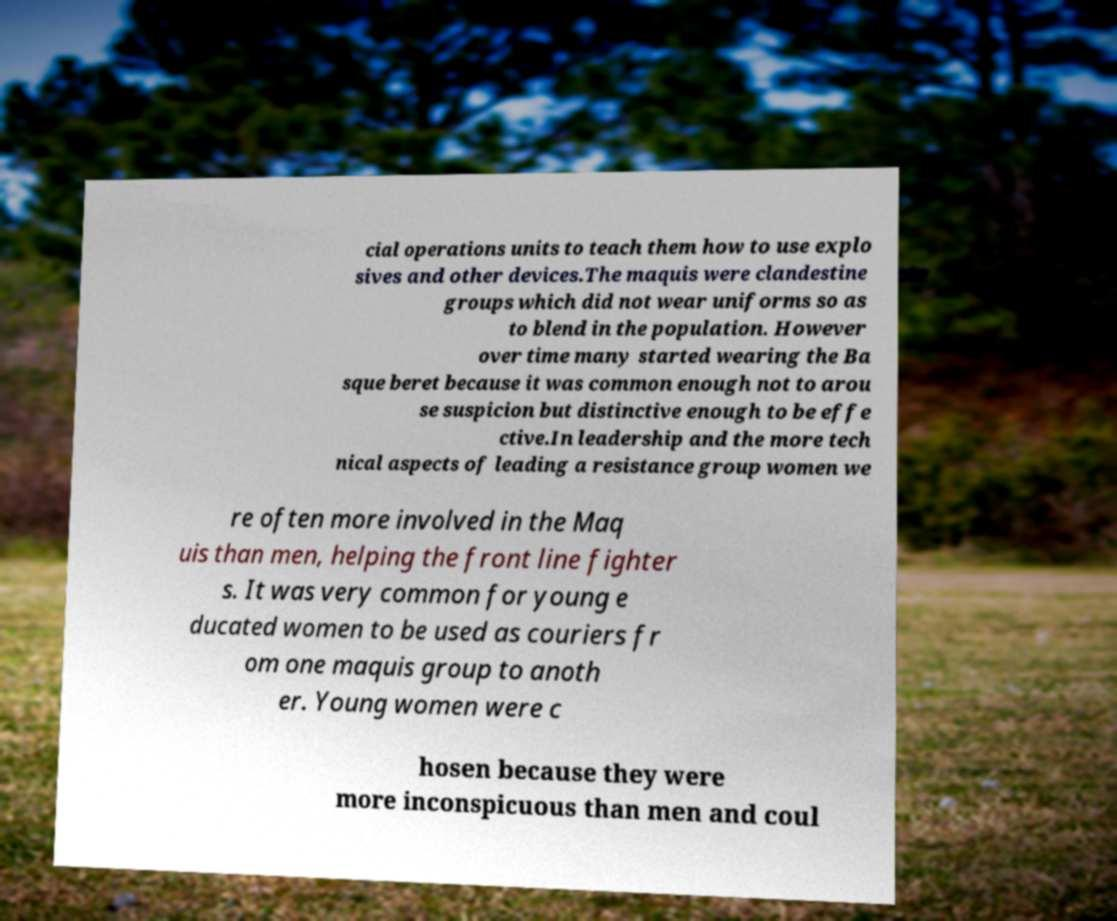Could you assist in decoding the text presented in this image and type it out clearly? cial operations units to teach them how to use explo sives and other devices.The maquis were clandestine groups which did not wear uniforms so as to blend in the population. However over time many started wearing the Ba sque beret because it was common enough not to arou se suspicion but distinctive enough to be effe ctive.In leadership and the more tech nical aspects of leading a resistance group women we re often more involved in the Maq uis than men, helping the front line fighter s. It was very common for young e ducated women to be used as couriers fr om one maquis group to anoth er. Young women were c hosen because they were more inconspicuous than men and coul 